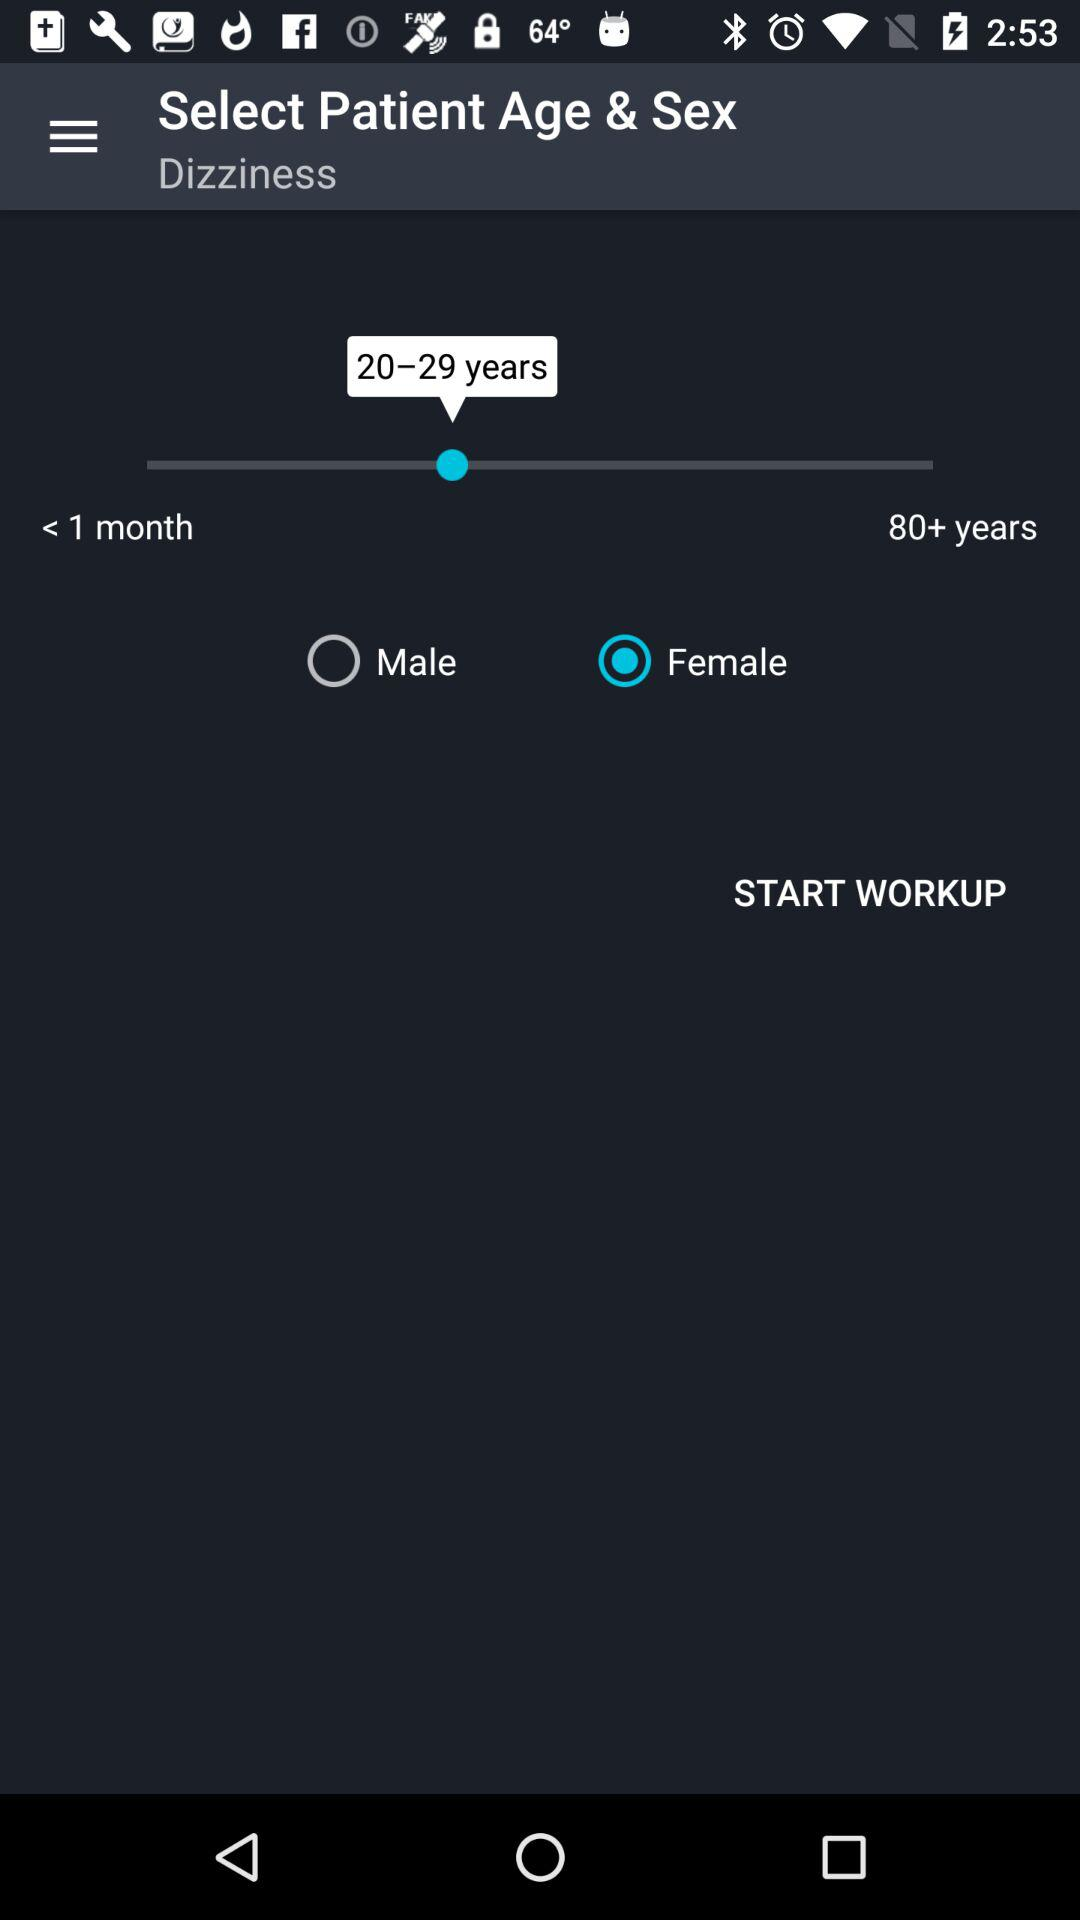What is the name of the health illness shown? The name of the health illness is "Dizziness". 